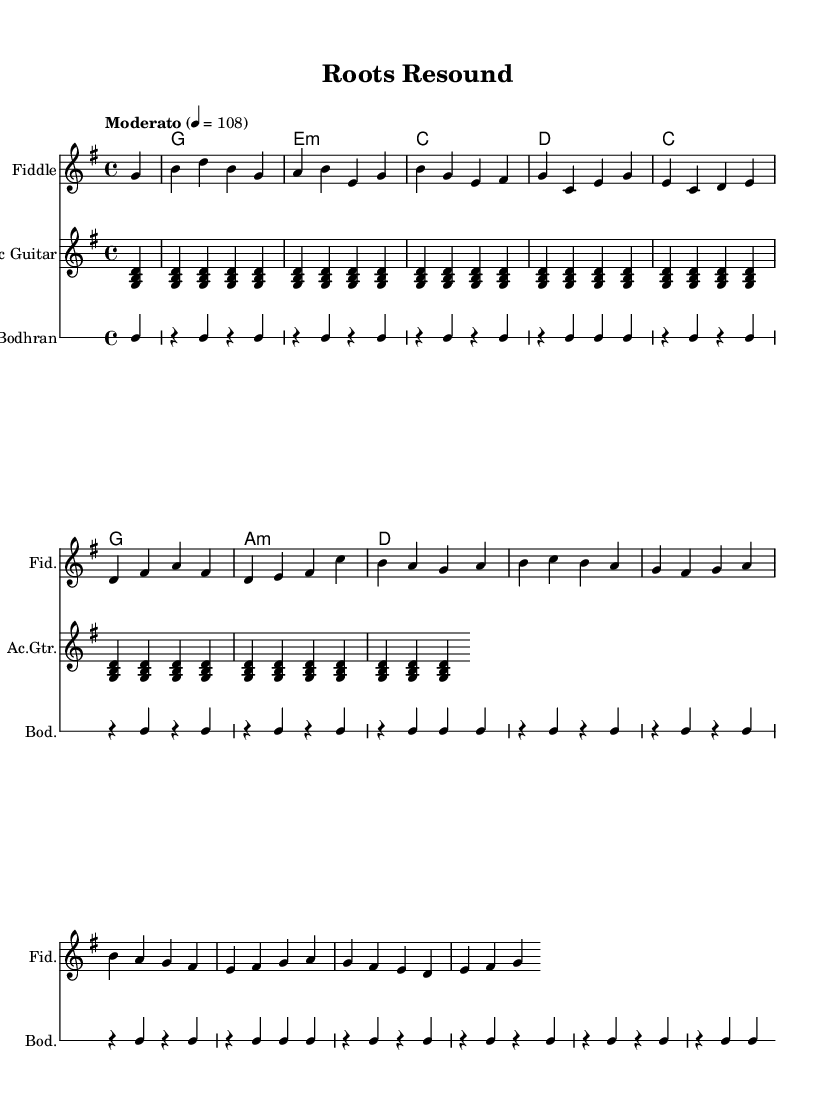What is the key signature of this music? The key signature is G major, which has one sharp (F#). This can be identified by looking at the beginning of the staff where the sharp is placed.
Answer: G major What is the time signature of this music? The time signature is 4/4, which is indicated at the beginning of the score. It means there are four beats in each measure and the quarter note gets one beat.
Answer: 4/4 What is the tempo marking for this piece? The tempo marking is "Moderato" indicating a moderate speed. This is defined at the start and is set to 108 beats per minute.
Answer: Moderato How many measures are there in the melody? The melody consists of 12 measures, which can be counted by looking at the vertical lines that separate each measure in the melody staff.
Answer: 12 Which traditional instrument is featured in this score? The featured traditional instrument is the Fiddle, noted in the "Staff" section with "instrumentName" designated as "Fiddle." The presence of this instrument is part of the fusion theme of the piece.
Answer: Fiddle What type of harmony is used throughout the score? The harmony used in this piece is diatonic, which corresponds to the main key (G major) and employs the chords typical for this key. The chord changes follow a logical progression suitable for pop music.
Answer: Diatonic What is the rhythmic pattern played by the Bodhran? The rhythmic pattern played by the Bodhran consists of a repeated figure primarily using quarter notes, which maintains a steady pulse essential for grounding the piece's rhythm. Counting the measures gives insight into this pattern.
Answer: Quarter notes 